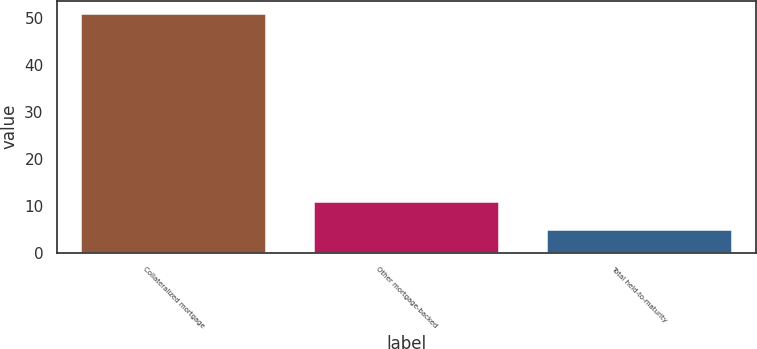Convert chart to OTSL. <chart><loc_0><loc_0><loc_500><loc_500><bar_chart><fcel>Collateralized mortgage<fcel>Other mortgage-backed<fcel>Total held-to-maturity<nl><fcel>51<fcel>11<fcel>5<nl></chart> 